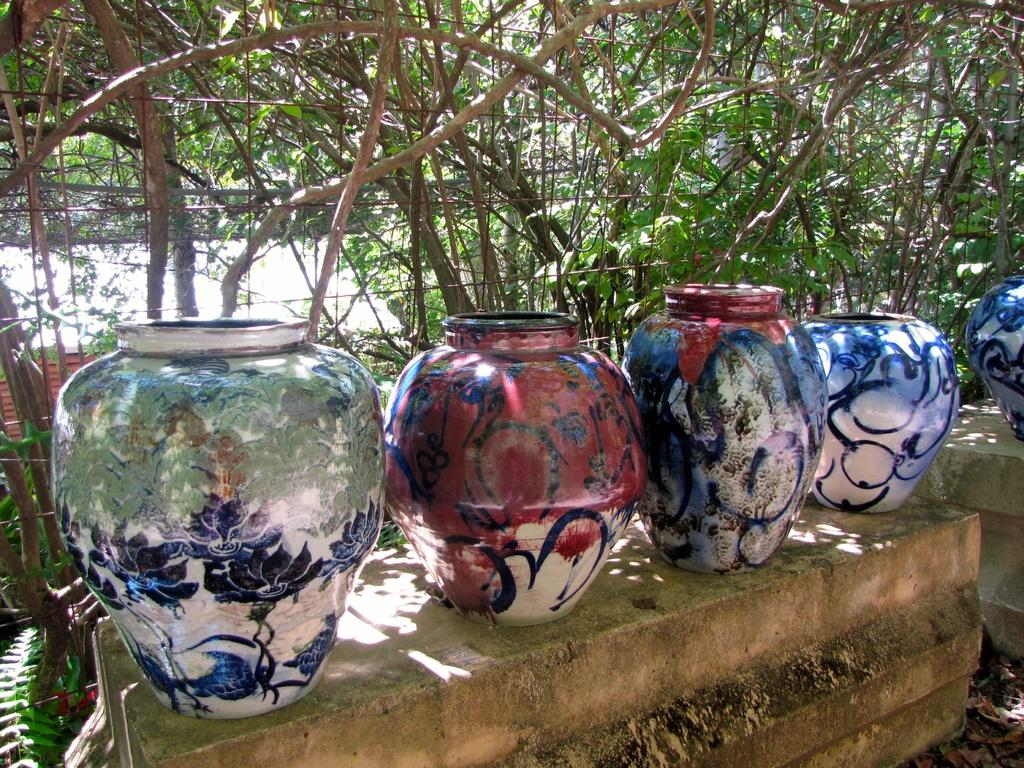What objects are in the foreground of the image? There are painted pots in the foreground of the image. What can be seen in the background of the image? There are trees and fencing in the background of the image. How many giraffes can be seen in the image? There are no giraffes present in the image. What attempt is being made by the person in the image? There is no person present in the image, so no attempt can be observed. 